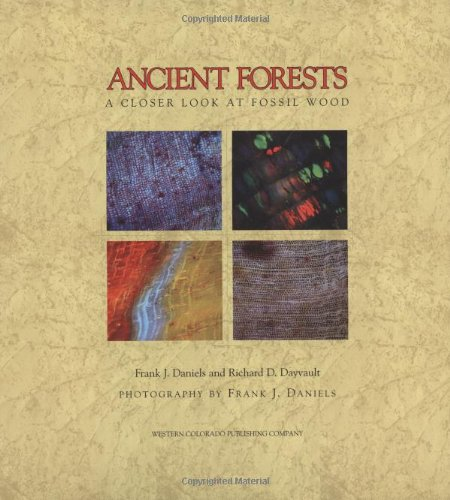What is the genre of this book? This book falls under the 'Science & Math' genre, specifically appealing to those interested in paleontology, geology, and natural history, providing a detailed scientific analysis of ancient forests preserved in stone. 